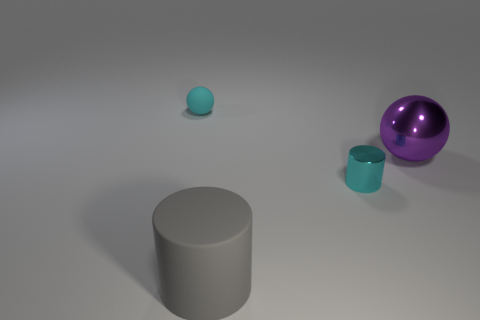Does the large gray rubber object have the same shape as the tiny cyan matte thing?
Offer a terse response. No. What number of other objects are the same material as the large cylinder?
Your answer should be compact. 1. How many other big things have the same shape as the big purple object?
Make the answer very short. 0. What is the color of the thing that is in front of the purple shiny object and on the left side of the cyan metallic thing?
Your answer should be compact. Gray. What number of brown balls are there?
Offer a terse response. 0. Does the cyan sphere have the same size as the purple thing?
Your answer should be compact. No. Are there any other shiny cylinders that have the same color as the big cylinder?
Make the answer very short. No. There is a rubber object that is behind the tiny shiny cylinder; is it the same shape as the tiny cyan shiny thing?
Provide a short and direct response. No. How many shiny cylinders are the same size as the cyan rubber thing?
Make the answer very short. 1. What number of gray cylinders are in front of the tiny object that is in front of the purple object?
Provide a succinct answer. 1. 